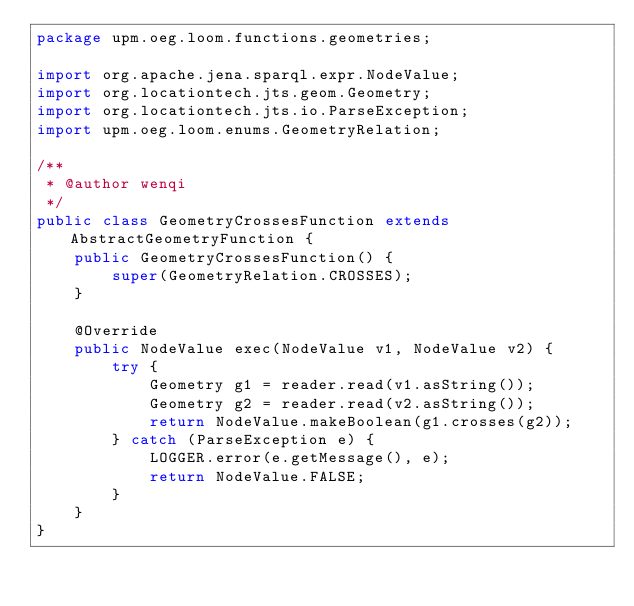<code> <loc_0><loc_0><loc_500><loc_500><_Java_>package upm.oeg.loom.functions.geometries;

import org.apache.jena.sparql.expr.NodeValue;
import org.locationtech.jts.geom.Geometry;
import org.locationtech.jts.io.ParseException;
import upm.oeg.loom.enums.GeometryRelation;

/**
 * @author wenqi
 */
public class GeometryCrossesFunction extends AbstractGeometryFunction {
    public GeometryCrossesFunction() {
        super(GeometryRelation.CROSSES);
    }

    @Override
    public NodeValue exec(NodeValue v1, NodeValue v2) {
        try {
            Geometry g1 = reader.read(v1.asString());
            Geometry g2 = reader.read(v2.asString());
            return NodeValue.makeBoolean(g1.crosses(g2));
        } catch (ParseException e) {
            LOGGER.error(e.getMessage(), e);
            return NodeValue.FALSE;
        }
    }
}
</code> 